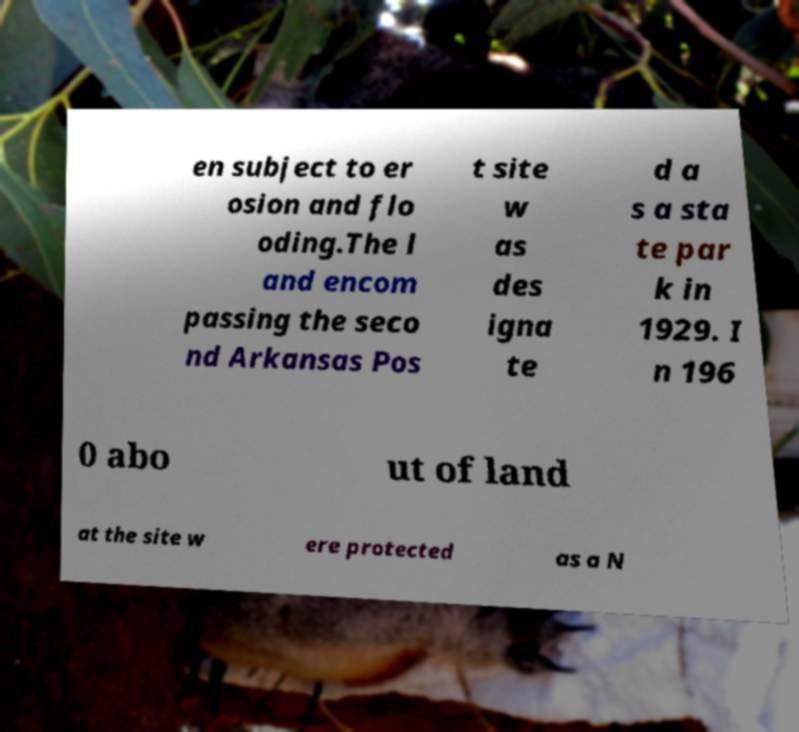Could you extract and type out the text from this image? en subject to er osion and flo oding.The l and encom passing the seco nd Arkansas Pos t site w as des igna te d a s a sta te par k in 1929. I n 196 0 abo ut of land at the site w ere protected as a N 